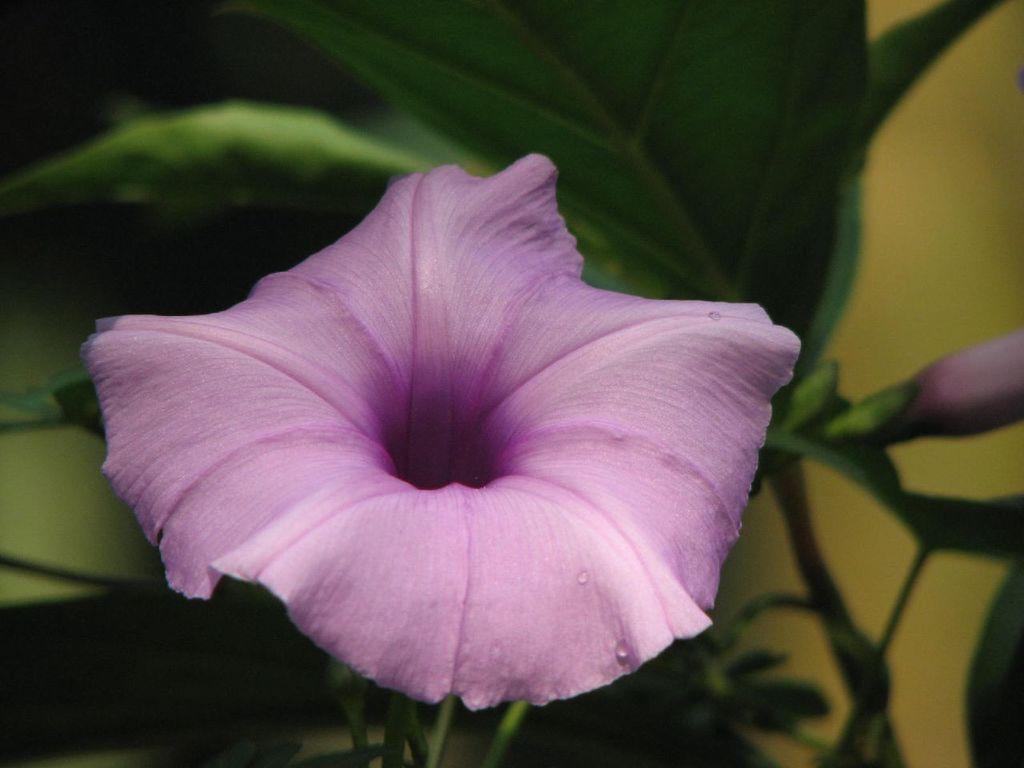In one or two sentences, can you explain what this image depicts? In this image we can see the flower, stems and also leaves. 